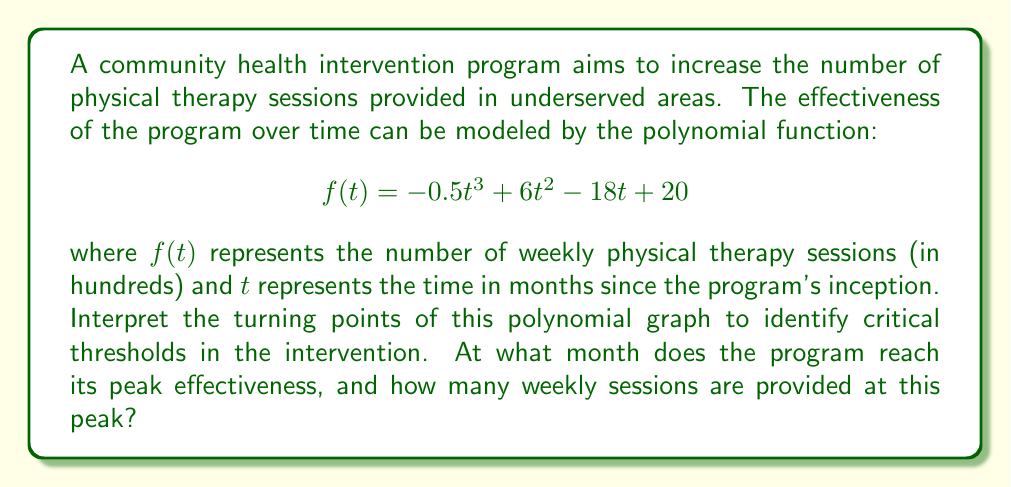Solve this math problem. To find the turning points of the polynomial graph, we need to follow these steps:

1) First, find the derivative of the function:
   $$f'(t) = -1.5t^2 + 12t - 18$$

2) Set the derivative equal to zero and solve for t:
   $$-1.5t^2 + 12t - 18 = 0$$

3) This is a quadratic equation. We can solve it using the quadratic formula:
   $$t = \frac{-b \pm \sqrt{b^2 - 4ac}}{2a}$$
   where $a = -1.5$, $b = 12$, and $c = -18$

4) Plugging in these values:
   $$t = \frac{-12 \pm \sqrt{12^2 - 4(-1.5)(-18)}}{2(-1.5)}$$
   $$= \frac{-12 \pm \sqrt{144 - 108}}{-3}$$
   $$= \frac{-12 \pm \sqrt{36}}{-3}$$
   $$= \frac{-12 \pm 6}{-3}$$

5) This gives us two solutions:
   $$t_1 = \frac{-12 + 6}{-3} = 2$$
   $$t_2 = \frac{-12 - 6}{-3} = 6$$

6) The second derivative is:
   $$f''(t) = -3t + 12$$

7) Evaluating the second derivative at $t = 2$ and $t = 6$:
   $$f''(2) = -3(2) + 12 = 6 > 0$$
   $$f''(6) = -3(6) + 12 = -6 < 0$$

8) Since $f''(2) > 0$, $t = 2$ is a local minimum.
   Since $f''(6) < 0$, $t = 6$ is a local maximum.

9) The peak effectiveness occurs at $t = 6$ months.

10) To find the number of sessions at the peak, evaluate $f(6)$:
    $$f(6) = -0.5(6^3) + 6(6^2) - 18(6) + 20$$
    $$= -108 + 216 - 108 + 20$$
    $$= 20$$

Therefore, the program reaches its peak effectiveness at 6 months, providing 2000 weekly physical therapy sessions.
Answer: 6 months; 2000 sessions 